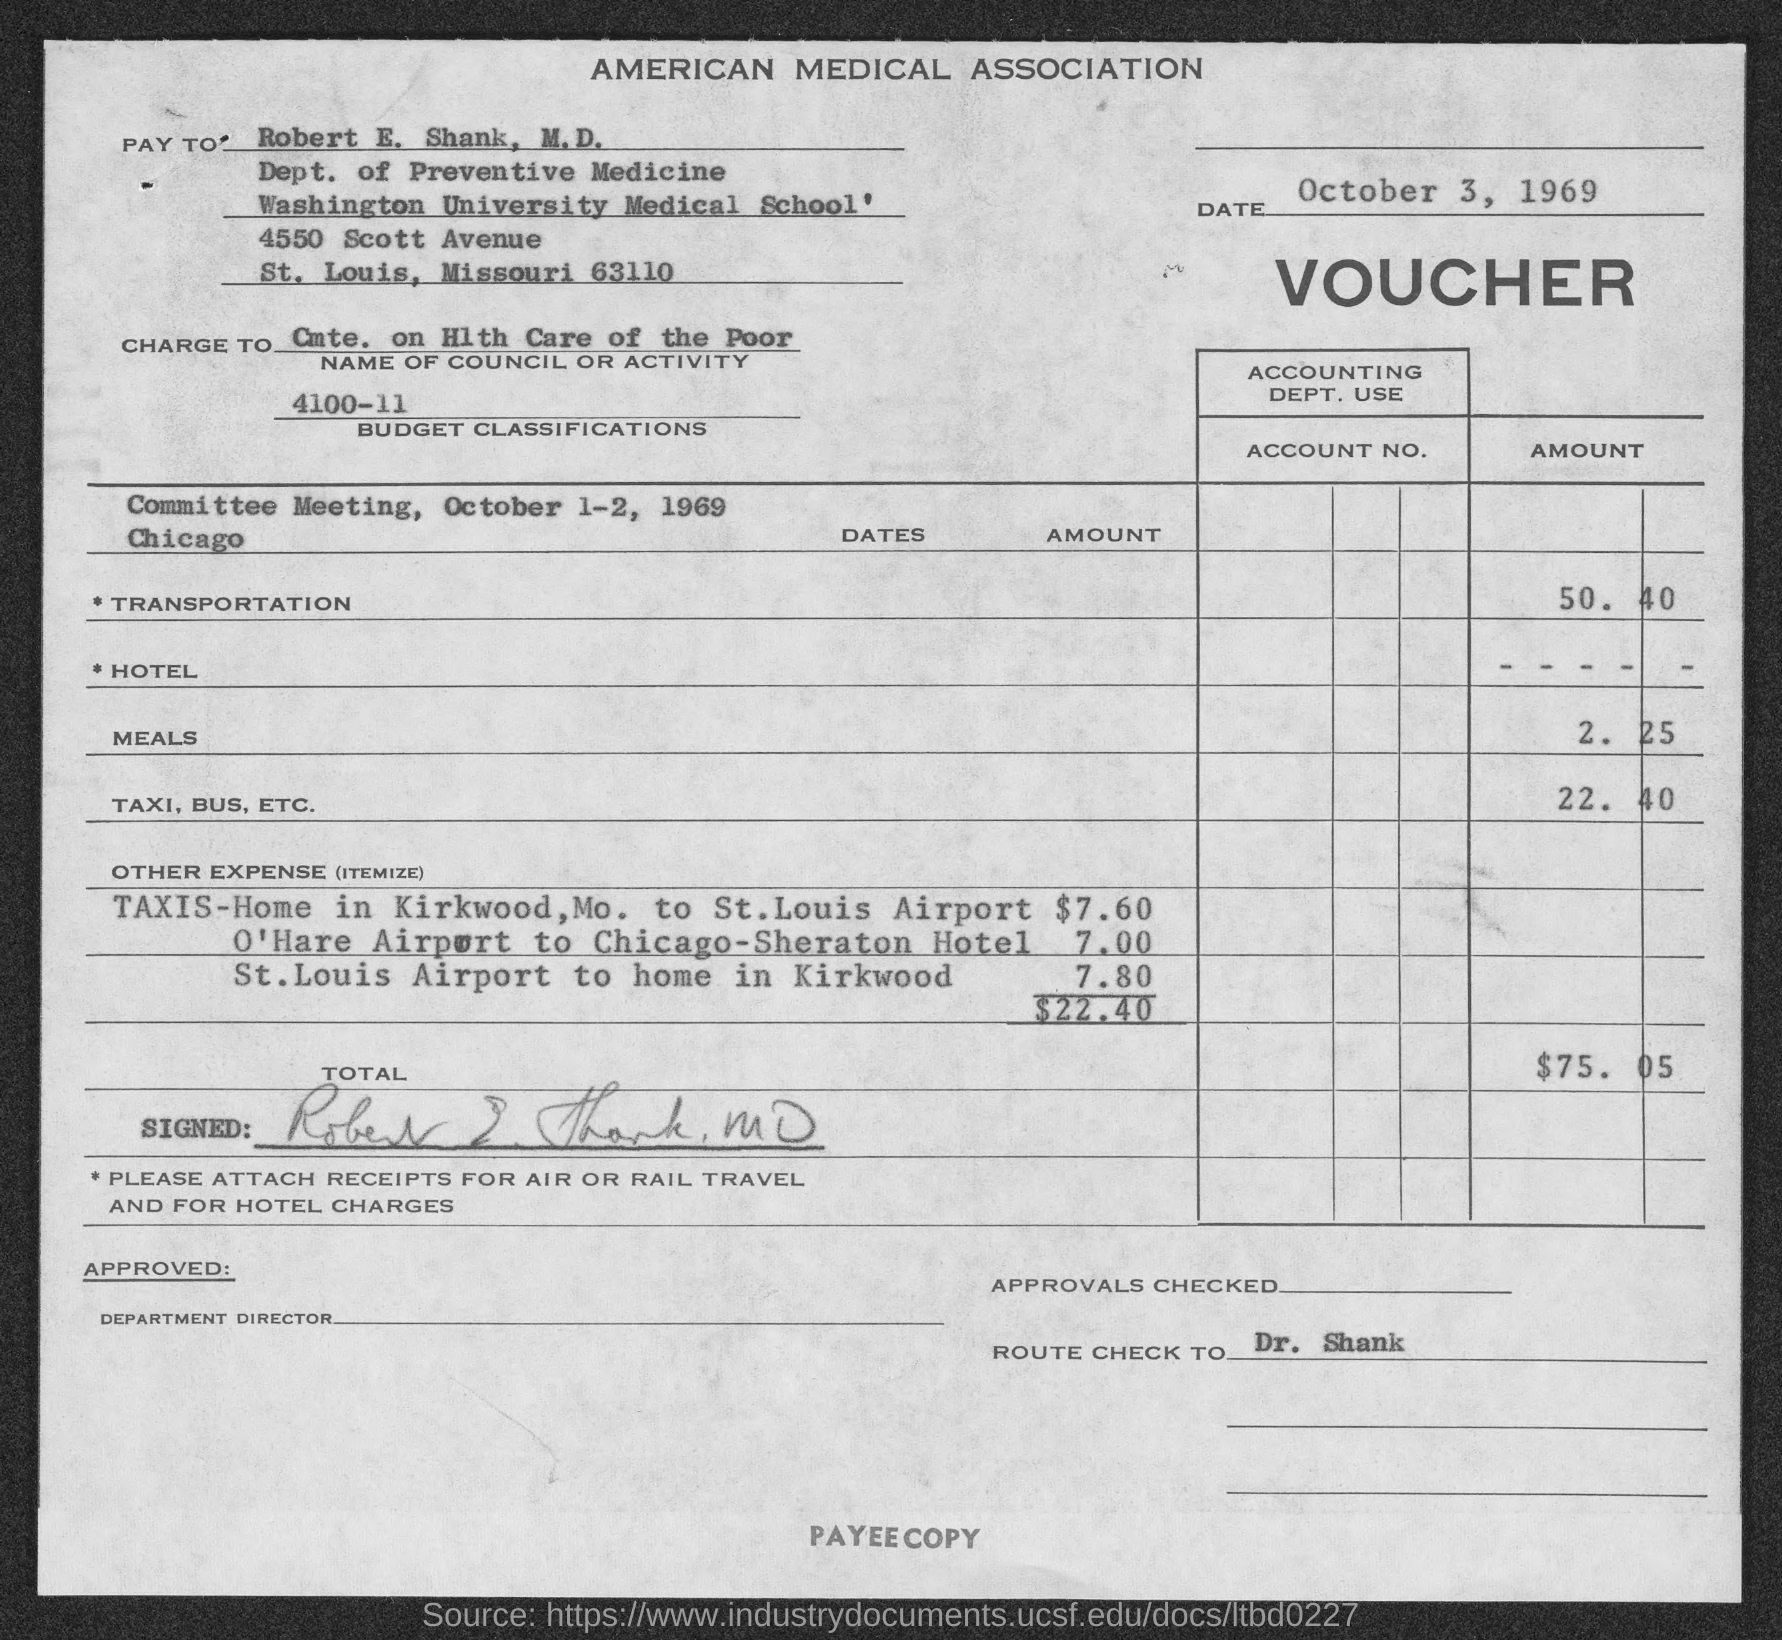Specify some key components in this picture. The voucher is to be paid to Robert E. Shank, M.D. The total amount of other expenses is $22.40. The name of the university mentioned in the given form is Washington University. The amount for transportation is 50.40. The date mentioned in the given page is October 3, 1969. 